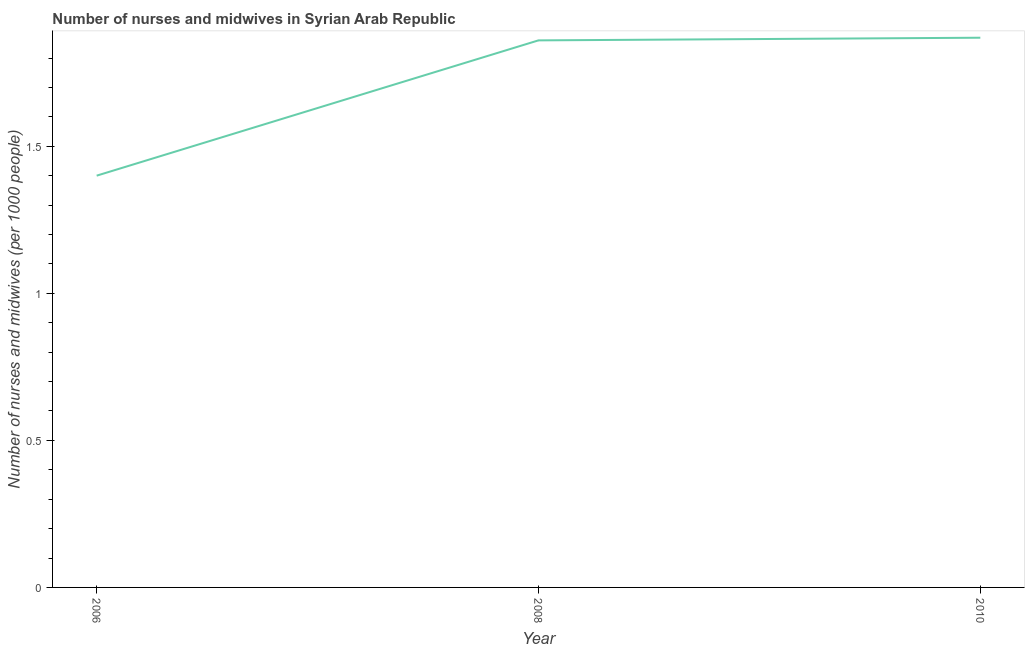What is the number of nurses and midwives in 2008?
Your answer should be compact. 1.86. Across all years, what is the maximum number of nurses and midwives?
Provide a short and direct response. 1.87. Across all years, what is the minimum number of nurses and midwives?
Make the answer very short. 1.4. In which year was the number of nurses and midwives maximum?
Give a very brief answer. 2010. In which year was the number of nurses and midwives minimum?
Offer a terse response. 2006. What is the sum of the number of nurses and midwives?
Offer a very short reply. 5.13. What is the difference between the number of nurses and midwives in 2008 and 2010?
Your answer should be compact. -0.01. What is the average number of nurses and midwives per year?
Keep it short and to the point. 1.71. What is the median number of nurses and midwives?
Your answer should be very brief. 1.86. In how many years, is the number of nurses and midwives greater than 1.5 ?
Ensure brevity in your answer.  2. What is the ratio of the number of nurses and midwives in 2008 to that in 2010?
Keep it short and to the point. 1. Is the number of nurses and midwives in 2006 less than that in 2008?
Your answer should be very brief. Yes. Is the difference between the number of nurses and midwives in 2008 and 2010 greater than the difference between any two years?
Offer a terse response. No. What is the difference between the highest and the second highest number of nurses and midwives?
Give a very brief answer. 0.01. Is the sum of the number of nurses and midwives in 2006 and 2008 greater than the maximum number of nurses and midwives across all years?
Your answer should be compact. Yes. What is the difference between the highest and the lowest number of nurses and midwives?
Your answer should be very brief. 0.47. Are the values on the major ticks of Y-axis written in scientific E-notation?
Make the answer very short. No. What is the title of the graph?
Make the answer very short. Number of nurses and midwives in Syrian Arab Republic. What is the label or title of the Y-axis?
Make the answer very short. Number of nurses and midwives (per 1000 people). What is the Number of nurses and midwives (per 1000 people) in 2006?
Offer a very short reply. 1.4. What is the Number of nurses and midwives (per 1000 people) of 2008?
Keep it short and to the point. 1.86. What is the Number of nurses and midwives (per 1000 people) of 2010?
Offer a terse response. 1.87. What is the difference between the Number of nurses and midwives (per 1000 people) in 2006 and 2008?
Make the answer very short. -0.46. What is the difference between the Number of nurses and midwives (per 1000 people) in 2006 and 2010?
Make the answer very short. -0.47. What is the difference between the Number of nurses and midwives (per 1000 people) in 2008 and 2010?
Your answer should be compact. -0.01. What is the ratio of the Number of nurses and midwives (per 1000 people) in 2006 to that in 2008?
Offer a terse response. 0.75. What is the ratio of the Number of nurses and midwives (per 1000 people) in 2006 to that in 2010?
Make the answer very short. 0.75. What is the ratio of the Number of nurses and midwives (per 1000 people) in 2008 to that in 2010?
Offer a very short reply. 0.99. 